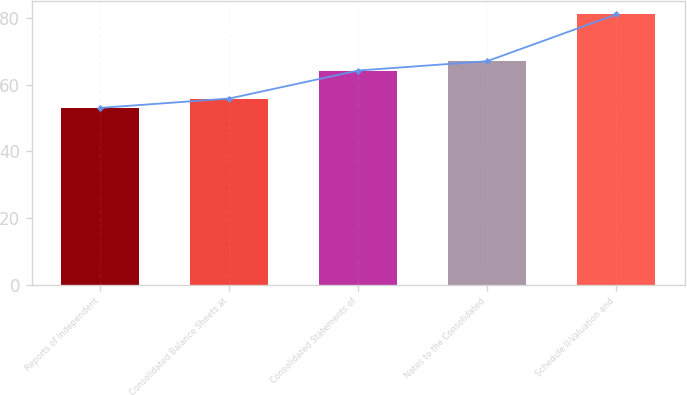Convert chart to OTSL. <chart><loc_0><loc_0><loc_500><loc_500><bar_chart><fcel>Reports of Independent<fcel>Consolidated Balance Sheets at<fcel>Consolidated Statements of<fcel>Notes to the Consolidated<fcel>Schedule II-Valuation and<nl><fcel>53<fcel>55.8<fcel>64.2<fcel>67<fcel>81<nl></chart> 